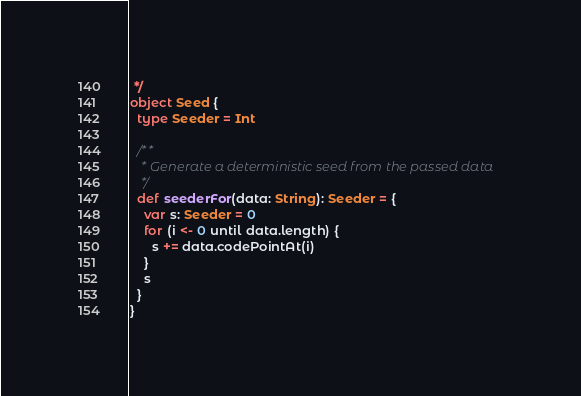<code> <loc_0><loc_0><loc_500><loc_500><_Scala_> */
object Seed {
  type Seeder = Int

  /**
   * Generate a deterministic seed from the passed data
   */
  def seederFor(data: String): Seeder = {
    var s: Seeder = 0
    for (i <- 0 until data.length) {
      s += data.codePointAt(i)
    }
    s
  }
}
</code> 